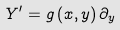Convert formula to latex. <formula><loc_0><loc_0><loc_500><loc_500>Y ^ { \prime } = g \left ( x , y \right ) \partial _ { y }</formula> 